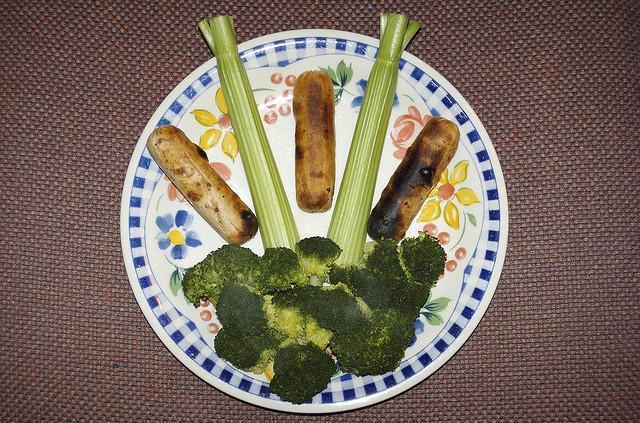How many hot dogs are there?
Give a very brief answer. 3. How many horses without riders?
Give a very brief answer. 0. 